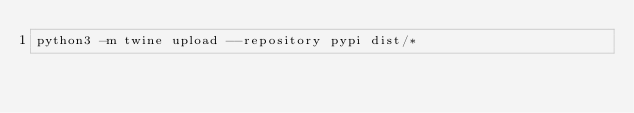<code> <loc_0><loc_0><loc_500><loc_500><_Bash_>python3 -m twine upload --repository pypi dist/*
</code> 